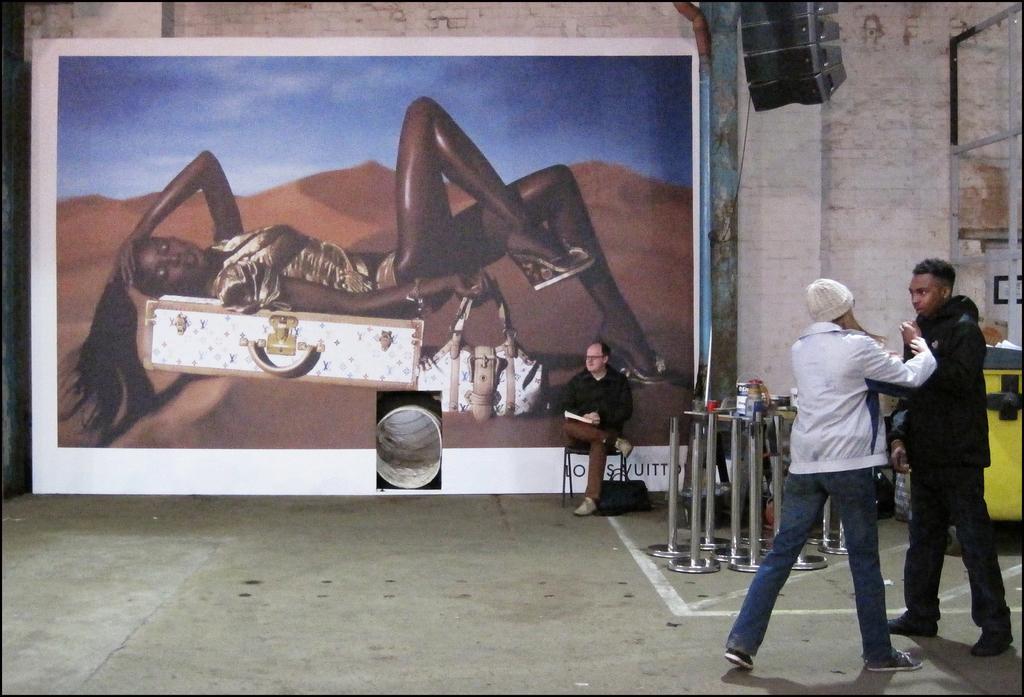Could you give a brief overview of what you see in this image? In this image I can see the group of people with different color dresses. To the side of these people I can see the fence rods and the many objects on the table. In the back I can see one person sitting on the chairs and holding something. To the side I can see the bag. I can see the banner to the wall. In the banner there is a person, box and bag on the sand. I can also see the sky in the banner. 